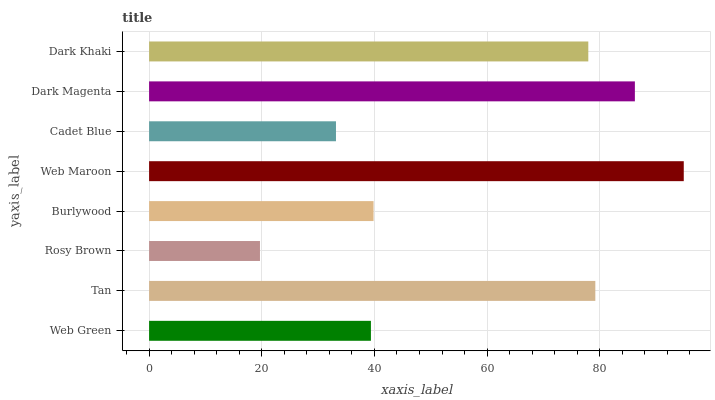Is Rosy Brown the minimum?
Answer yes or no. Yes. Is Web Maroon the maximum?
Answer yes or no. Yes. Is Tan the minimum?
Answer yes or no. No. Is Tan the maximum?
Answer yes or no. No. Is Tan greater than Web Green?
Answer yes or no. Yes. Is Web Green less than Tan?
Answer yes or no. Yes. Is Web Green greater than Tan?
Answer yes or no. No. Is Tan less than Web Green?
Answer yes or no. No. Is Dark Khaki the high median?
Answer yes or no. Yes. Is Burlywood the low median?
Answer yes or no. Yes. Is Cadet Blue the high median?
Answer yes or no. No. Is Tan the low median?
Answer yes or no. No. 